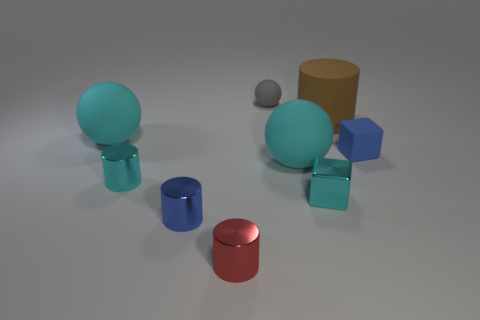What is the shape of the big cyan rubber thing to the right of the small cyan cylinder?
Ensure brevity in your answer.  Sphere. How many other things are there of the same size as the brown cylinder?
Keep it short and to the point. 2. There is a cyan rubber thing that is to the right of the small blue metal thing; is it the same shape as the tiny rubber thing that is on the right side of the brown rubber cylinder?
Provide a succinct answer. No. There is a tiny blue matte object; how many blue matte things are in front of it?
Offer a very short reply. 0. What is the color of the small object that is right of the brown rubber object?
Your answer should be compact. Blue. There is a rubber object that is the same shape as the blue metal object; what color is it?
Your answer should be compact. Brown. Is there any other thing that has the same color as the tiny matte cube?
Keep it short and to the point. Yes. Are there more small green metallic spheres than tiny blue rubber things?
Your answer should be compact. No. Do the big brown cylinder and the cyan cylinder have the same material?
Provide a succinct answer. No. How many brown things have the same material as the red object?
Your answer should be compact. 0. 